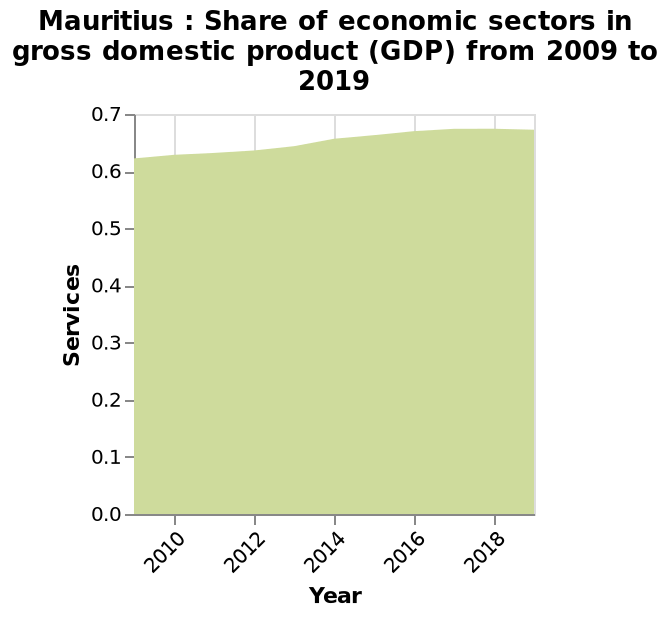<image>
How is the share of economic services in GDP changing over time in Mauritius? The share of economic services in GDP is steadily rising over time in Mauritius. please describe the details of the chart Here a is a area diagram titled Mauritius : Share of economic sectors in gross domestic product (GDP) from 2009 to 2019. There is a scale with a minimum of 0.0 and a maximum of 0.7 on the y-axis, marked Services. Along the x-axis, Year is measured. Is the share of economic services in GDP increasing or decreasing in Mauritius? The share of economic services in GDP is steadily increasing in Mauritius. 